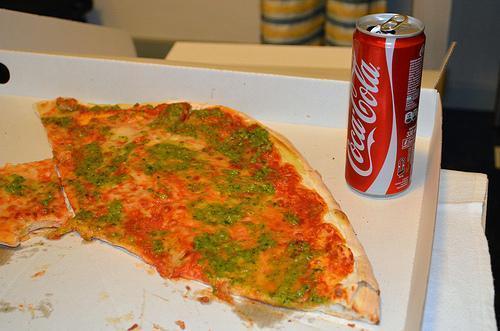How many people are in this picture?
Give a very brief answer. 0. How many whole slices of pizza are left?
Give a very brief answer. 3. How many animals are pictured here?
Give a very brief answer. 0. 